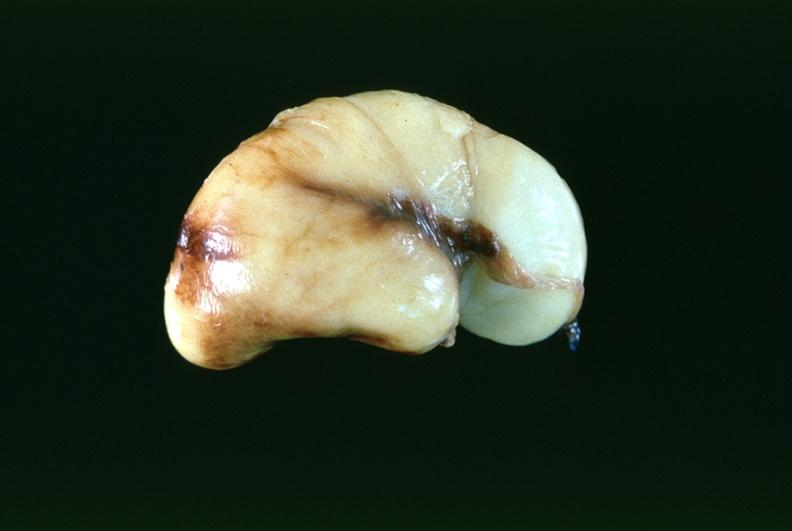what does this image show?
Answer the question using a single word or phrase. Brain 